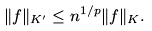Convert formula to latex. <formula><loc_0><loc_0><loc_500><loc_500>\| f \| _ { K ^ { \prime } } \leq n ^ { 1 / p } \| f \| _ { K } .</formula> 